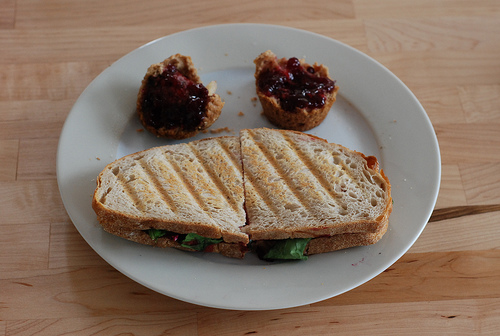How many zebras are there? There are actually no zebras in the image. It appears to be a photo showing a plate with a sandwich cut in half and two halves of an English muffin served with what looks like jam on top. 